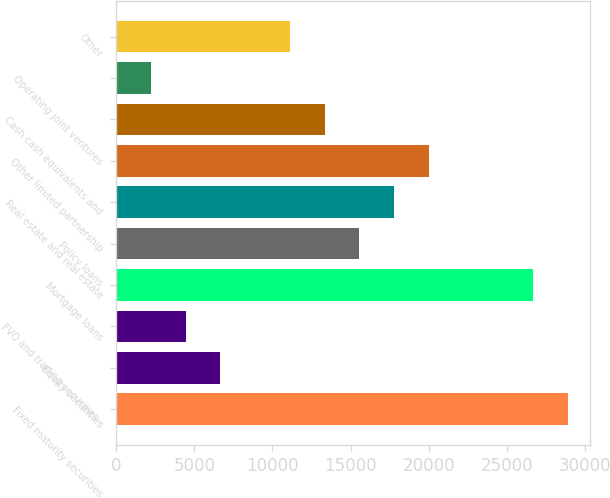<chart> <loc_0><loc_0><loc_500><loc_500><bar_chart><fcel>Fixed maturity securities<fcel>Equity securities<fcel>FVO and trading securities -<fcel>Mortgage loans<fcel>Policy loans<fcel>Real estate and real estate<fcel>Other limited partnership<fcel>Cash cash equivalents and<fcel>Operating joint ventures<fcel>Other<nl><fcel>28900.7<fcel>6671.7<fcel>4448.8<fcel>26677.8<fcel>15563.3<fcel>17786.2<fcel>20009.1<fcel>13340.4<fcel>2225.9<fcel>11117.5<nl></chart> 